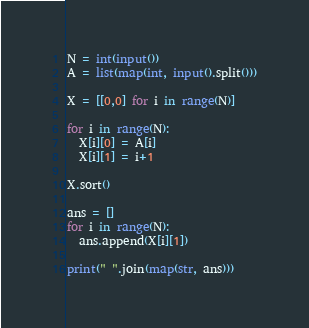Convert code to text. <code><loc_0><loc_0><loc_500><loc_500><_Python_>N = int(input())
A = list(map(int, input().split()))

X = [[0,0] for i in range(N)]

for i in range(N):
  X[i][0] = A[i]
  X[i][1] = i+1
  
X.sort()

ans = []
for i in range(N):
  ans.append(X[i][1])
  
print(" ".join(map(str, ans)))</code> 